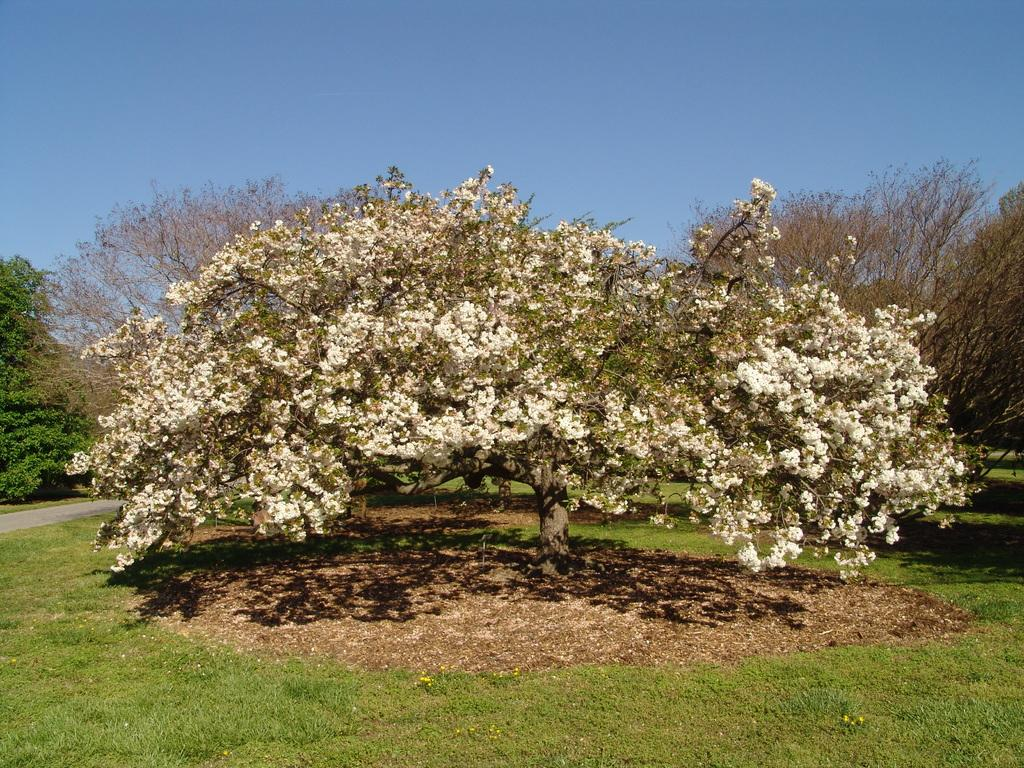What type of vegetation is present in the image? There are many trees in the image. What can be seen at the bottom of the image? The grass is visible at the bottom of the image. What is visible at the top of the image? The sky is visible at the top of the image. Where is the library located in the image? There is no library present in the image; it features trees, grass, and the sky. Can you see a friend in the image? There is no friend present in the image; it only features natural elements like trees, grass, and the sky. 